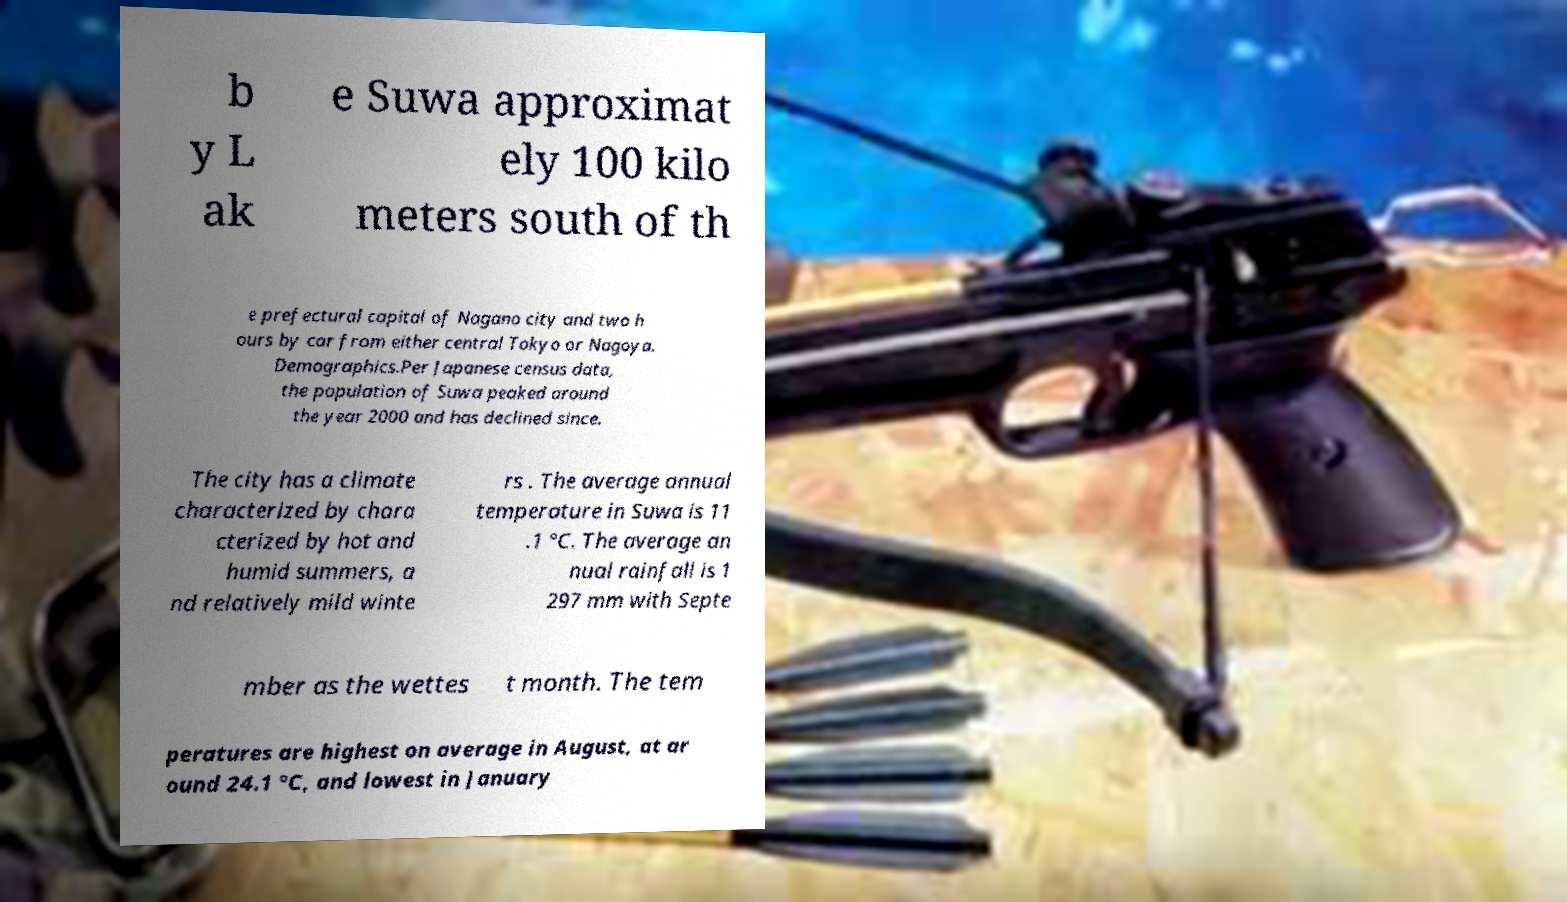There's text embedded in this image that I need extracted. Can you transcribe it verbatim? b y L ak e Suwa approximat ely 100 kilo meters south of th e prefectural capital of Nagano city and two h ours by car from either central Tokyo or Nagoya. Demographics.Per Japanese census data, the population of Suwa peaked around the year 2000 and has declined since. The city has a climate characterized by chara cterized by hot and humid summers, a nd relatively mild winte rs . The average annual temperature in Suwa is 11 .1 °C. The average an nual rainfall is 1 297 mm with Septe mber as the wettes t month. The tem peratures are highest on average in August, at ar ound 24.1 °C, and lowest in January 